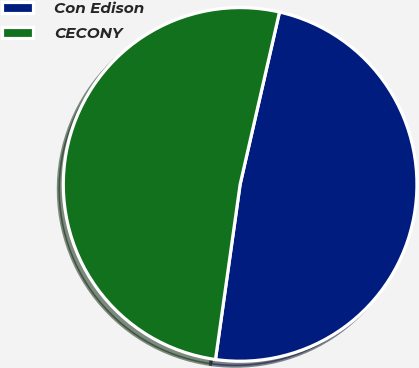<chart> <loc_0><loc_0><loc_500><loc_500><pie_chart><fcel>Con Edison<fcel>CECONY<nl><fcel>48.65%<fcel>51.35%<nl></chart> 